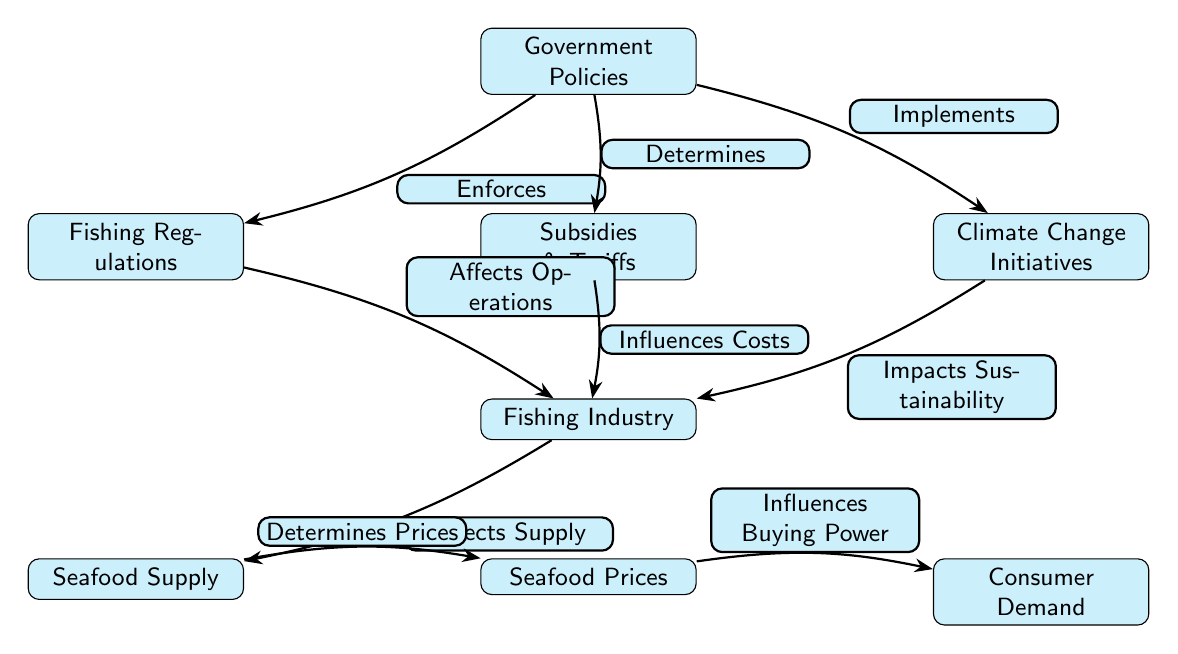What are the three main subcategories under Government Policies? According to the diagram, Government Policies lead to three subcategories: Fishing Regulations, Subsidies & Tariffs, and Climate Change Initiatives. Counting these gives us a total of three main subcategories.
Answer: three What type of relationship exists between Fishing Regulations and Fishing Industry? The diagram indicates that Fishing Regulations "Affect Operations" in the Fishing Industry. This relationship implies that regulations directly influence how the fishing industry operates.
Answer: Affects Operations Which node directly influences Seafood Prices? Tracing the flow, we see that Seafood Prices are directly influenced by Seafood Supply according to the phrase "Determines Prices" in the diagram. This indicates a direct connection between the two nodes.
Answer: Seafood Supply What does the node Climate Change Initiatives impact? The diagram shows that Climate Change Initiatives "Impacts Sustainability" of the Fishing Industry. Hence, it tells us that sustainability efforts from climate policies aim to affect the fishing industry's practices.
Answer: Sustainability Which two nodes are linked to Seafood Supply? Following the arrows, Seafood Supply is linked to Fishing Industry and Seafood Prices. The diagram indicates that Fishing Industry "Affects Supply," and Seafood Supply further connects to Seafood Prices as it "Determines Prices."
Answer: Fishing Industry and Seafood Prices How many edges are there in the diagram? To count the edges, we can follow each connection from one node to another. Based on the diagram, there are a total of six connections linking the nodes together, hence the count of edges is six.
Answer: six What do the Government Policies enforce? The diagram specifies that Government Policies "Enforces" Fishing Regulations. This means that the government's political actions are directed towards establishing and ensuring adherence to fishing regulations.
Answer: Fishing Regulations What is the last output of the diagram's flow? By following the flow, we see that the final output of the chain leads to Consumer Demand, which is influenced by Seafood Prices. Thus, we conclude that Consumer Demand is the last output connected in this sequence.
Answer: Consumer Demand Which node influences Consumer Demand directly? The only node that directly influences Consumer Demand in the diagram is Seafood Prices, as indicated by "Influences Buying Power." This shows that the prices of seafood has a direct impact on consumer choices.
Answer: Seafood Prices 